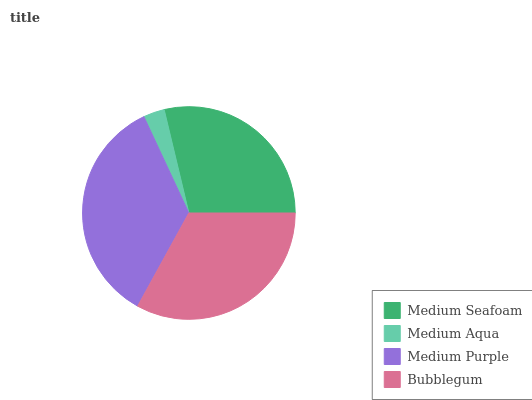Is Medium Aqua the minimum?
Answer yes or no. Yes. Is Medium Purple the maximum?
Answer yes or no. Yes. Is Medium Purple the minimum?
Answer yes or no. No. Is Medium Aqua the maximum?
Answer yes or no. No. Is Medium Purple greater than Medium Aqua?
Answer yes or no. Yes. Is Medium Aqua less than Medium Purple?
Answer yes or no. Yes. Is Medium Aqua greater than Medium Purple?
Answer yes or no. No. Is Medium Purple less than Medium Aqua?
Answer yes or no. No. Is Bubblegum the high median?
Answer yes or no. Yes. Is Medium Seafoam the low median?
Answer yes or no. Yes. Is Medium Purple the high median?
Answer yes or no. No. Is Medium Aqua the low median?
Answer yes or no. No. 